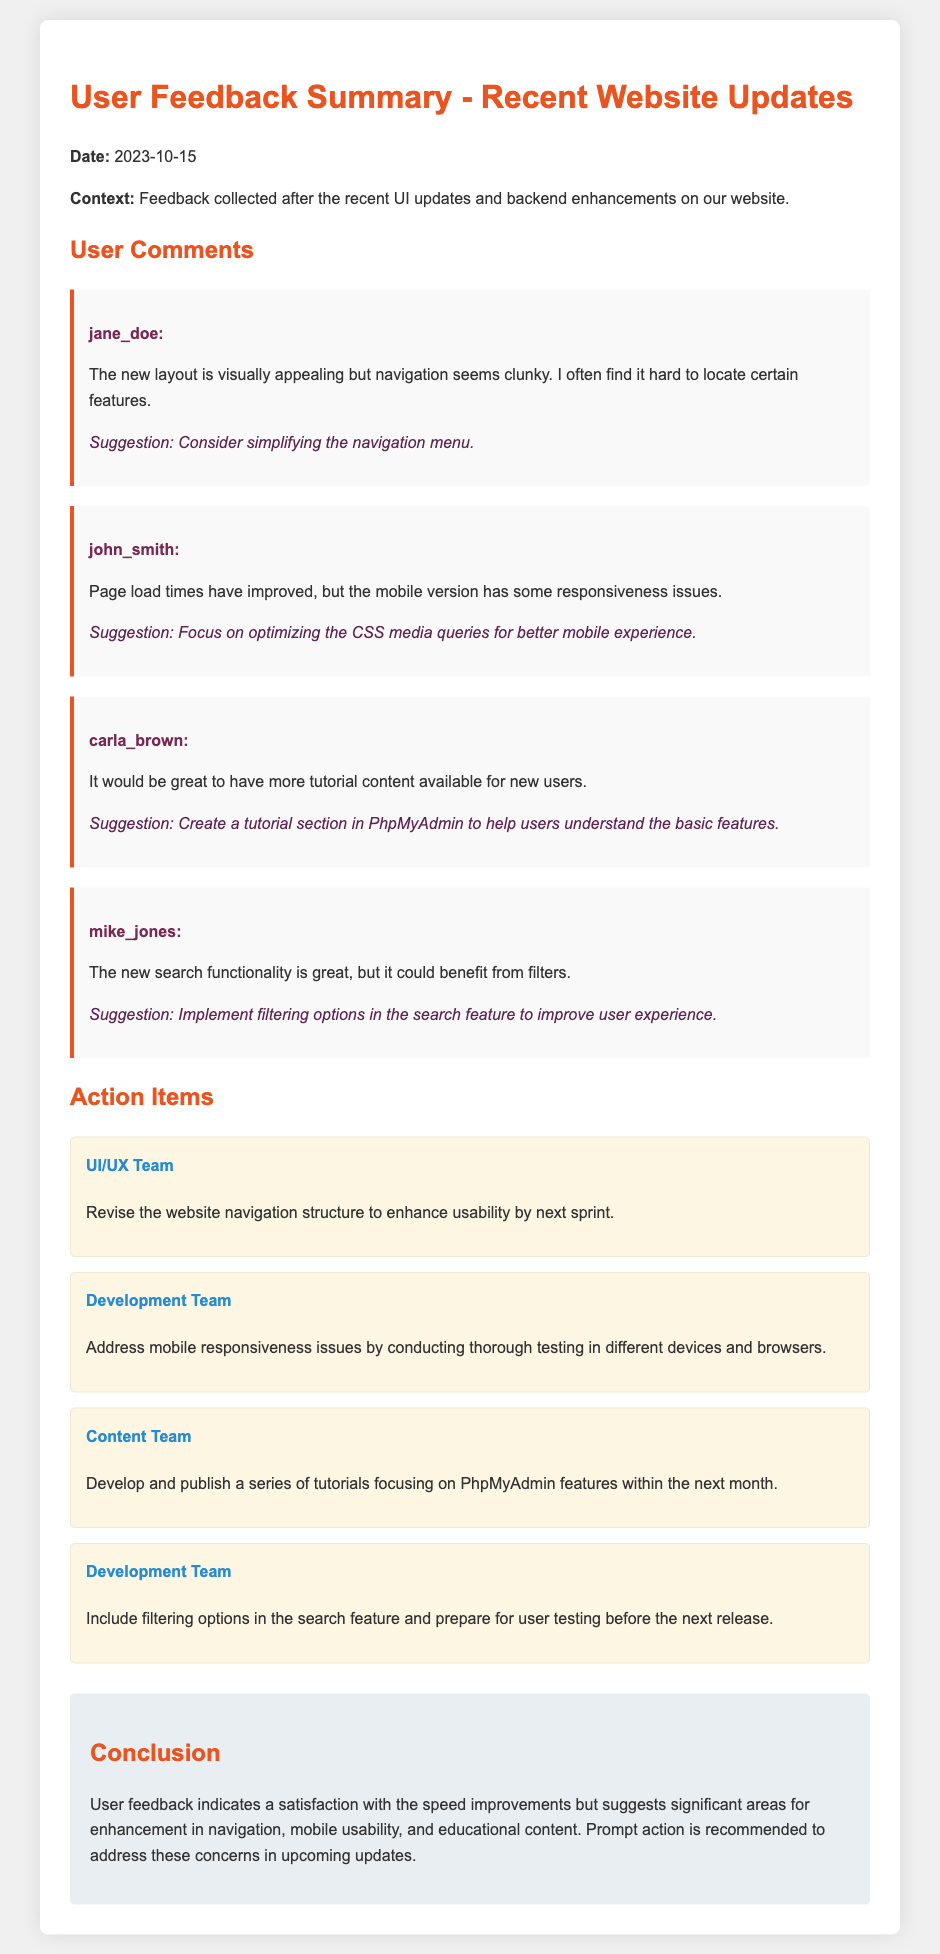What is the date of the feedback summary? The date is mentioned at the beginning of the document, which is 2023-10-15.
Answer: 2023-10-15 Who provided the suggestion to create a tutorial section in PhpMyAdmin? The suggestion about the tutorial section was made by the user "carla_brown" in the comments.
Answer: carla_brown What is one of the main suggestions given by john_smith? john_smith suggested focusing on optimizing the CSS media queries for better mobile experience.
Answer: Optimize CSS media queries How many action items are listed for the Development Team? The document specifies that there are two action items listed for the Development Team.
Answer: 2 What is the conclusion regarding user feedback? The conclusion summarizes that user feedback indicates satisfaction with speed improvements but highlights areas for enhancement in navigation, mobile usability, and educational content.
Answer: Significant areas for enhancement Which team is responsible for revising the navigation structure? The UI/UX Team is assigned to revise the website navigation structure as an action item.
Answer: UI/UX Team What specific improvement did mike_jones suggest for the search functionality? mike_jones suggested implementing filtering options in the search feature to improve user experience.
Answer: Filtering options How many user comments are included in the summary? There are four user comments provided in the feedback summary.
Answer: 4 What is the background color of the comments section? The comments section has a background color of #f9f9f9.
Answer: #f9f9f9 